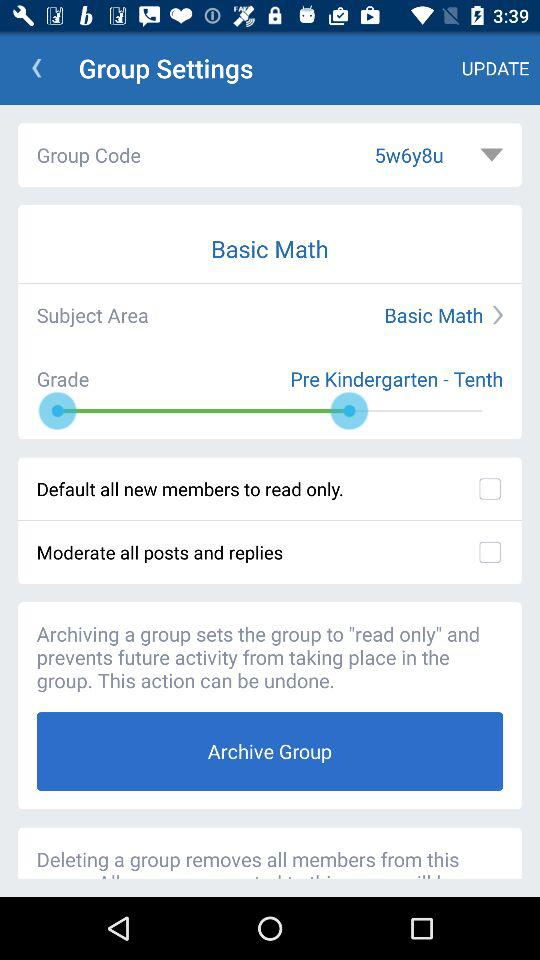What's the group code? The group code is "5w6y8u". 